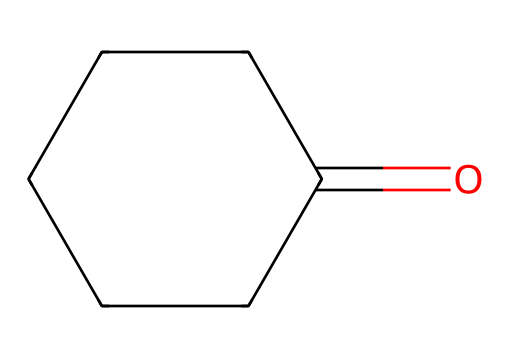What is the name of the molecule represented by this structure? The SMILES representation corresponds to cyclohexanone, which has a six-membered carbon ring with a ketone functional group.
Answer: cyclohexanone How many carbon atoms are in cyclohexanone? Counting the carbon atoms in the SMILES notation O=C1CCCCC1 indicates that there are six carbon atoms in total in the ring structure.
Answer: six What functional group is present in cyclohexanone? The structure indicates a carbonyl group (C=O) is present, which is characteristic of ketones.
Answer: carbonyl What is the total number of hydrogen atoms in cyclohexanone? For a cyclic ketone like cyclohexanone, the formula is CnH2nO, which leads to six hydrogen atoms when n is six.
Answer: twelve Is cyclohexanone polar or nonpolar? Due to the presence of the polar carbonyl group and the molecular structure, cyclohexanone is polar.
Answer: polar How does the structure of cyclohexanone relate to its reactivity? The presence of the carbonyl group in ketones makes them more reactive compared to alkanes; it is a site for nucleophilic attack.
Answer: carbonyl group What type of chemical is cyclohexanone classified as? Cyclohexanone is classified as a ketone because of the presence of the carbonyl group bonded to two carbon atoms in a ring structure.
Answer: ketone 